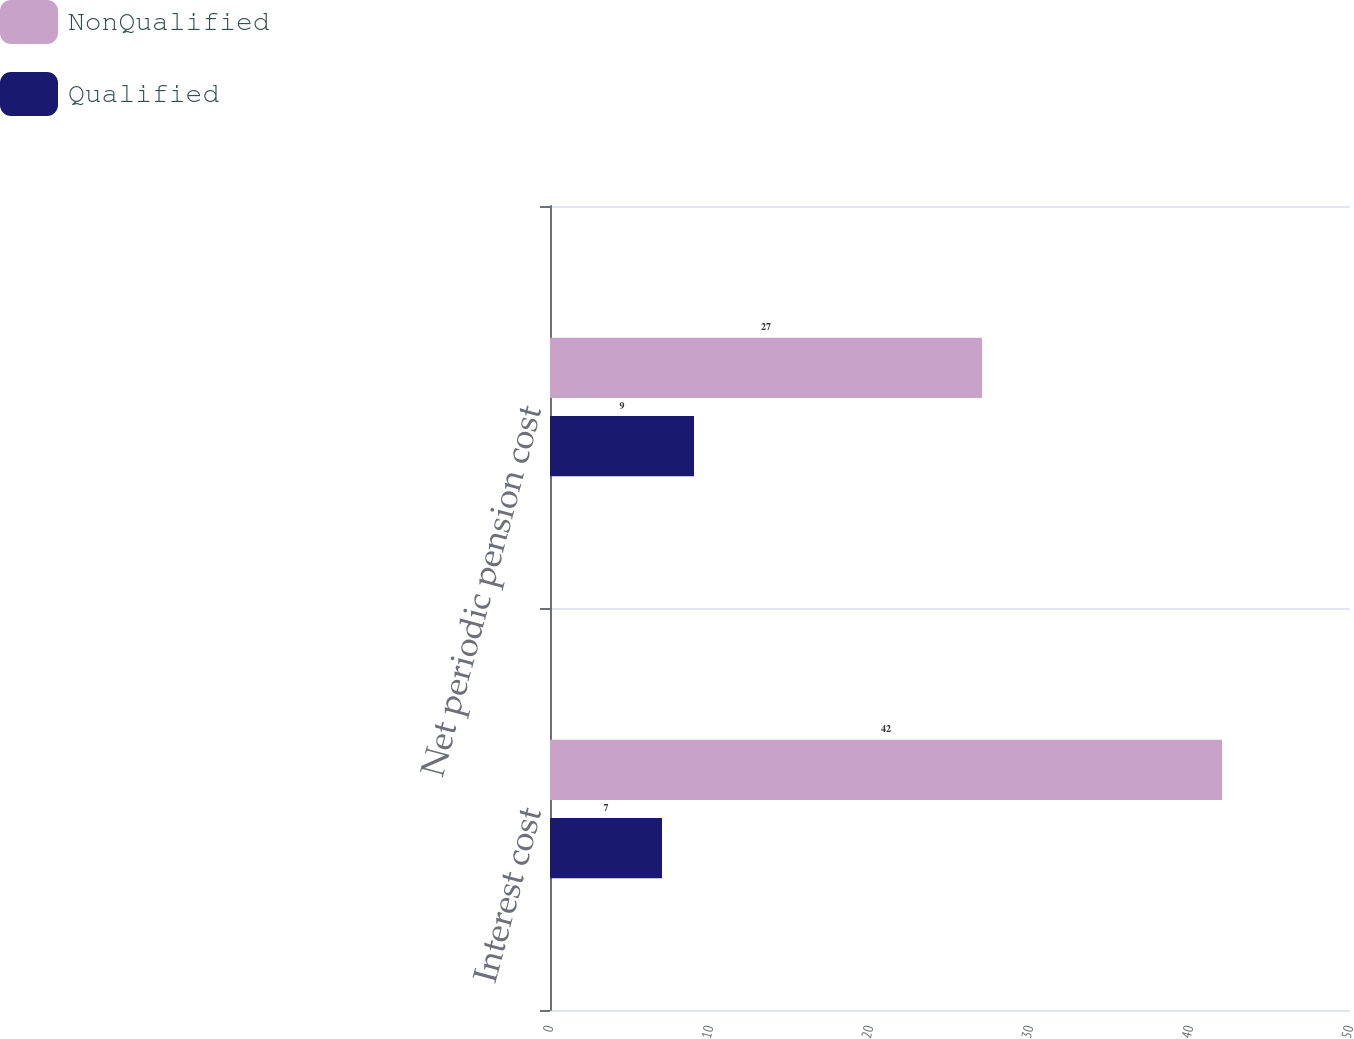Convert chart to OTSL. <chart><loc_0><loc_0><loc_500><loc_500><stacked_bar_chart><ecel><fcel>Interest cost<fcel>Net periodic pension cost<nl><fcel>NonQualified<fcel>42<fcel>27<nl><fcel>Qualified<fcel>7<fcel>9<nl></chart> 